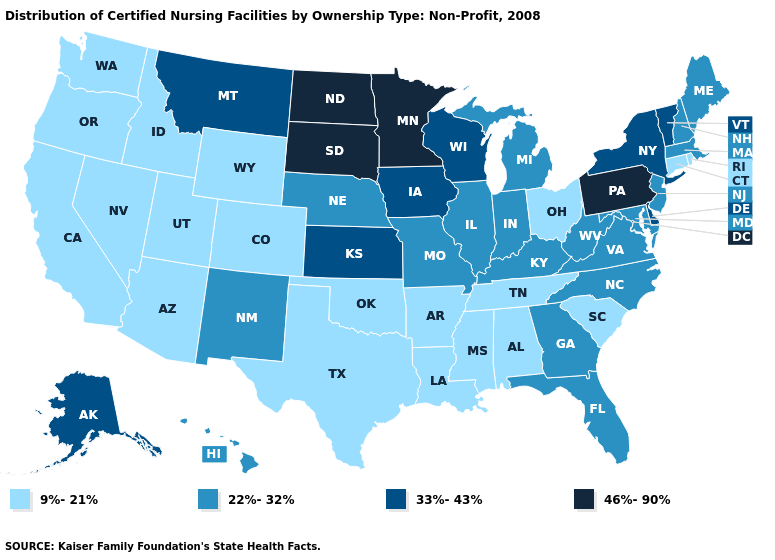Does South Dakota have the highest value in the MidWest?
Be succinct. Yes. Name the states that have a value in the range 46%-90%?
Be succinct. Minnesota, North Dakota, Pennsylvania, South Dakota. What is the value of Kentucky?
Be succinct. 22%-32%. Which states hav the highest value in the South?
Concise answer only. Delaware. Does Oregon have the lowest value in the USA?
Be succinct. Yes. What is the value of New York?
Give a very brief answer. 33%-43%. Name the states that have a value in the range 46%-90%?
Write a very short answer. Minnesota, North Dakota, Pennsylvania, South Dakota. What is the value of Connecticut?
Keep it brief. 9%-21%. Does the map have missing data?
Short answer required. No. What is the value of New Hampshire?
Keep it brief. 22%-32%. Name the states that have a value in the range 33%-43%?
Quick response, please. Alaska, Delaware, Iowa, Kansas, Montana, New York, Vermont, Wisconsin. What is the lowest value in states that border Michigan?
Keep it brief. 9%-21%. What is the lowest value in the USA?
Short answer required. 9%-21%. What is the value of Colorado?
Write a very short answer. 9%-21%. 